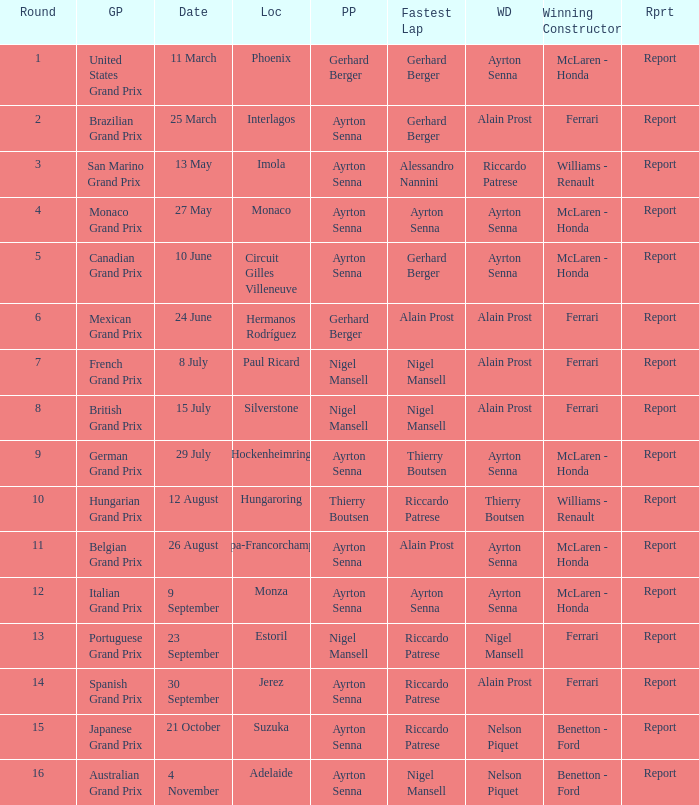What was the constructor when riccardo patrese was the winning driver? Williams - Renault. 